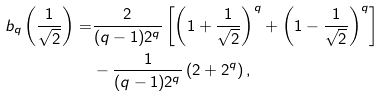<formula> <loc_0><loc_0><loc_500><loc_500>b _ { q } \left ( \frac { 1 } { \sqrt { 2 } } \right ) = & \frac { 2 } { ( q - 1 ) 2 ^ { q } } \left [ \left ( 1 + \frac { 1 } { \sqrt { 2 } } \right ) ^ { q } + \left ( 1 - \frac { 1 } { \sqrt { 2 } } \right ) ^ { q } \right ] \\ & - \frac { 1 } { ( q - 1 ) 2 ^ { q } } \left ( 2 + 2 ^ { q } \right ) ,</formula> 